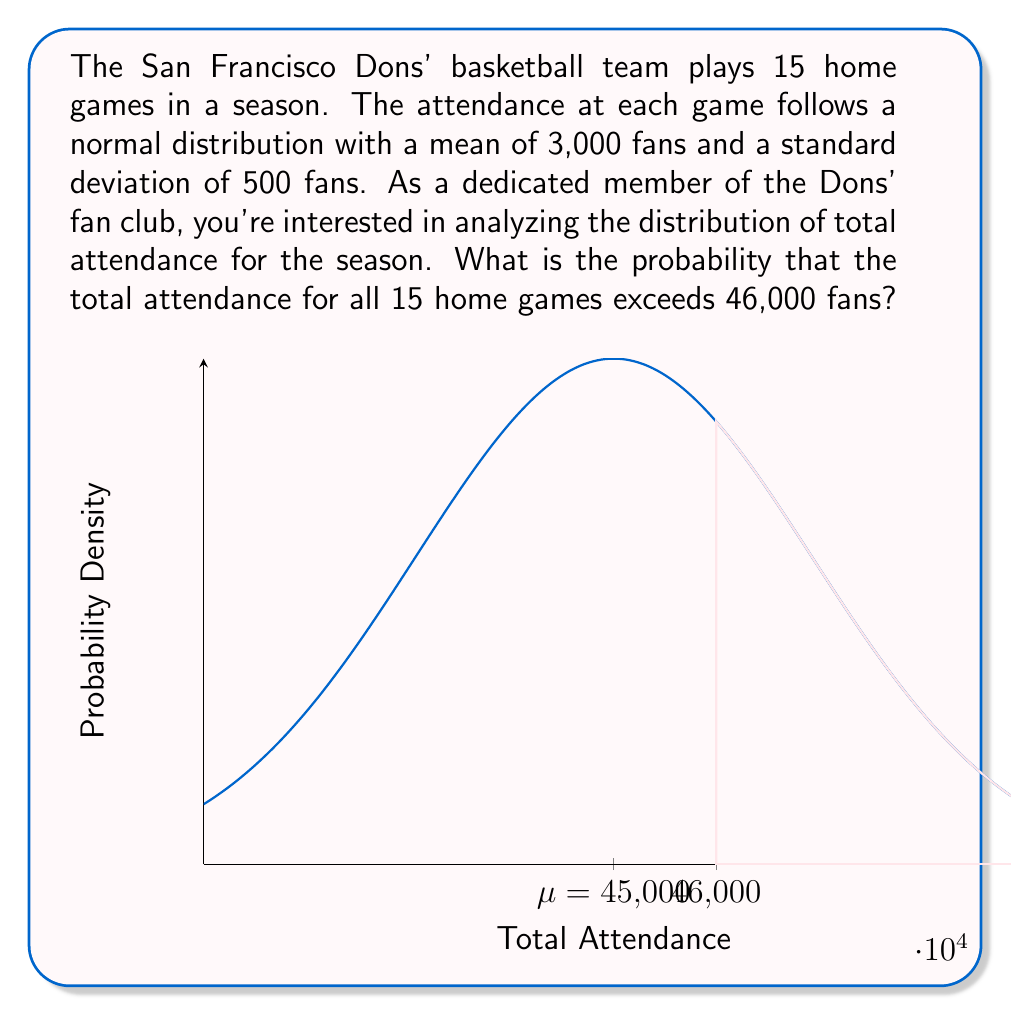What is the answer to this math problem? Let's approach this step-by-step:

1) First, we need to understand what we're dealing with. We have 15 independent games, each with attendance following a normal distribution N(3000, 500²).

2) The total attendance for the season is the sum of these 15 independent normal distributions. According to the properties of normal distributions, the sum of independent normal distributions is also normally distributed.

3) To find the parameters of this new distribution:
   
   Mean: $\mu_{total} = 15 \times 3000 = 45000$ fans
   
   Variance: $\sigma^2_{total} = 15 \times 500^2 = 3,750,000$
   
   Standard deviation: $\sigma_{total} = \sqrt{3,750,000} = 1936.49$ fans

4) So, the total attendance follows N(45000, 1936.49²).

5) We want to find P(Total Attendance > 46000)

6) To standardize this, we calculate the z-score:

   $$z = \frac{x - \mu}{\sigma} = \frac{46000 - 45000}{1936.49} = 0.5164$$

7) Now, we need to find P(Z > 0.5164) where Z is a standard normal variable.

8) Using a standard normal table or calculator, we find:

   P(Z > 0.5164) = 1 - P(Z < 0.5164) = 1 - 0.6972 = 0.3028

Therefore, the probability that the total attendance for all 15 home games exceeds 46,000 fans is approximately 0.3028 or 30.28%.
Answer: 0.3028 